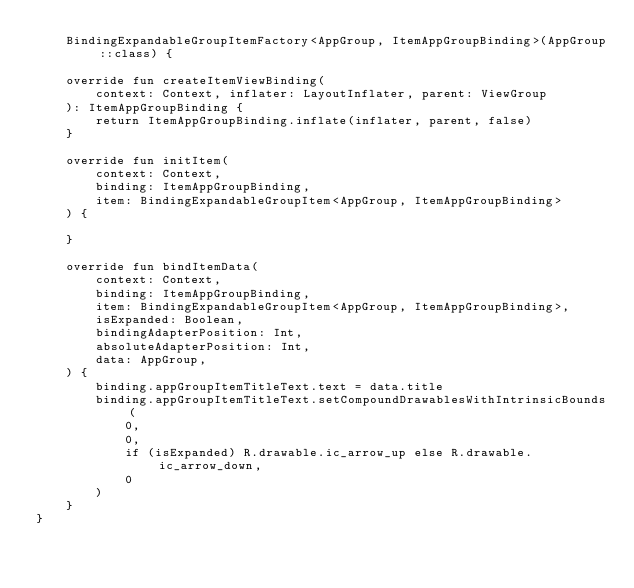<code> <loc_0><loc_0><loc_500><loc_500><_Kotlin_>    BindingExpandableGroupItemFactory<AppGroup, ItemAppGroupBinding>(AppGroup::class) {

    override fun createItemViewBinding(
        context: Context, inflater: LayoutInflater, parent: ViewGroup
    ): ItemAppGroupBinding {
        return ItemAppGroupBinding.inflate(inflater, parent, false)
    }

    override fun initItem(
        context: Context,
        binding: ItemAppGroupBinding,
        item: BindingExpandableGroupItem<AppGroup, ItemAppGroupBinding>
    ) {

    }

    override fun bindItemData(
        context: Context,
        binding: ItemAppGroupBinding,
        item: BindingExpandableGroupItem<AppGroup, ItemAppGroupBinding>,
        isExpanded: Boolean,
        bindingAdapterPosition: Int,
        absoluteAdapterPosition: Int,
        data: AppGroup,
    ) {
        binding.appGroupItemTitleText.text = data.title
        binding.appGroupItemTitleText.setCompoundDrawablesWithIntrinsicBounds(
            0,
            0,
            if (isExpanded) R.drawable.ic_arrow_up else R.drawable.ic_arrow_down,
            0
        )
    }
}
</code> 